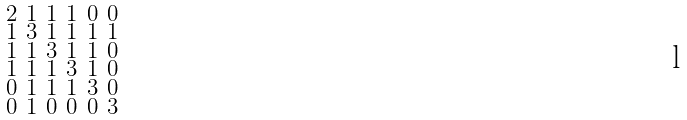Convert formula to latex. <formula><loc_0><loc_0><loc_500><loc_500>\begin{smallmatrix} 2 & 1 & 1 & 1 & 0 & 0 \\ 1 & 3 & 1 & 1 & 1 & 1 \\ 1 & 1 & 3 & 1 & 1 & 0 \\ 1 & 1 & 1 & 3 & 1 & 0 \\ 0 & 1 & 1 & 1 & 3 & 0 \\ 0 & 1 & 0 & 0 & 0 & 3 \end{smallmatrix}</formula> 